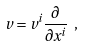<formula> <loc_0><loc_0><loc_500><loc_500>v = v ^ { i } \frac { \partial } { \partial x ^ { i } } \ ,</formula> 